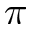<formula> <loc_0><loc_0><loc_500><loc_500>\pi</formula> 